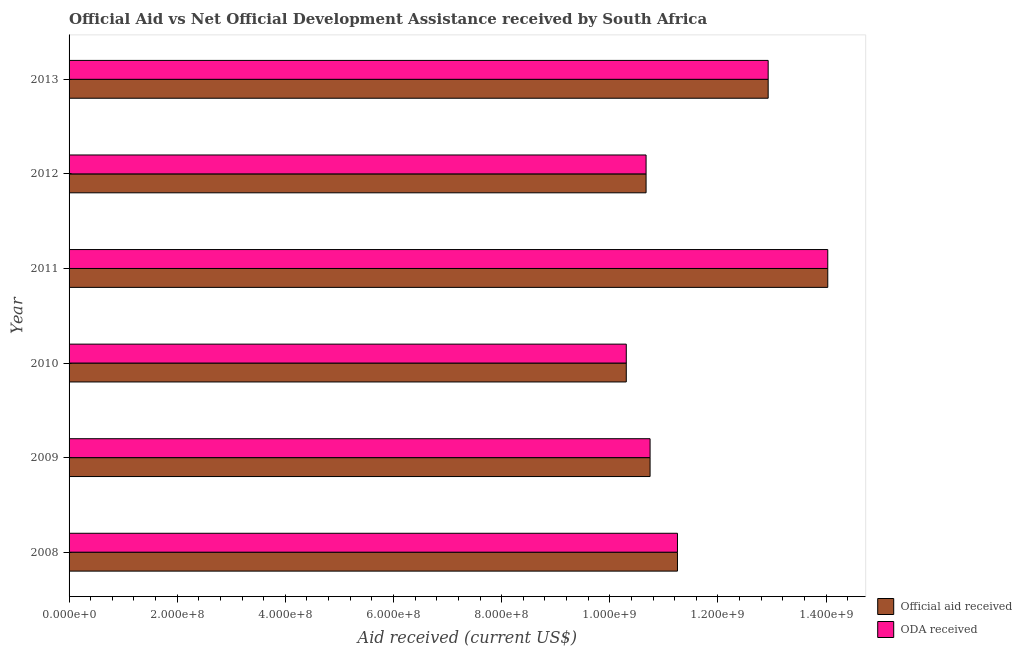How many different coloured bars are there?
Give a very brief answer. 2. Are the number of bars on each tick of the Y-axis equal?
Keep it short and to the point. Yes. What is the oda received in 2013?
Give a very brief answer. 1.29e+09. Across all years, what is the maximum oda received?
Give a very brief answer. 1.40e+09. Across all years, what is the minimum oda received?
Offer a very short reply. 1.03e+09. In which year was the oda received maximum?
Your answer should be compact. 2011. In which year was the oda received minimum?
Offer a terse response. 2010. What is the total oda received in the graph?
Give a very brief answer. 6.99e+09. What is the difference between the oda received in 2008 and that in 2010?
Keep it short and to the point. 9.46e+07. What is the difference between the oda received in 2013 and the official aid received in 2011?
Your answer should be very brief. -1.10e+08. What is the average official aid received per year?
Keep it short and to the point. 1.17e+09. In the year 2008, what is the difference between the oda received and official aid received?
Ensure brevity in your answer.  0. What is the ratio of the oda received in 2011 to that in 2013?
Make the answer very short. 1.08. Is the difference between the oda received in 2012 and 2013 greater than the difference between the official aid received in 2012 and 2013?
Keep it short and to the point. No. What is the difference between the highest and the second highest oda received?
Offer a very short reply. 1.10e+08. What is the difference between the highest and the lowest official aid received?
Offer a very short reply. 3.73e+08. Is the sum of the oda received in 2009 and 2011 greater than the maximum official aid received across all years?
Offer a terse response. Yes. What does the 1st bar from the top in 2008 represents?
Provide a short and direct response. ODA received. What does the 1st bar from the bottom in 2009 represents?
Make the answer very short. Official aid received. Are all the bars in the graph horizontal?
Give a very brief answer. Yes. How many years are there in the graph?
Ensure brevity in your answer.  6. What is the difference between two consecutive major ticks on the X-axis?
Offer a very short reply. 2.00e+08. Where does the legend appear in the graph?
Your answer should be very brief. Bottom right. How many legend labels are there?
Ensure brevity in your answer.  2. What is the title of the graph?
Your response must be concise. Official Aid vs Net Official Development Assistance received by South Africa . What is the label or title of the X-axis?
Make the answer very short. Aid received (current US$). What is the label or title of the Y-axis?
Offer a terse response. Year. What is the Aid received (current US$) of Official aid received in 2008?
Ensure brevity in your answer.  1.13e+09. What is the Aid received (current US$) of ODA received in 2008?
Provide a short and direct response. 1.13e+09. What is the Aid received (current US$) in Official aid received in 2009?
Your response must be concise. 1.07e+09. What is the Aid received (current US$) in ODA received in 2009?
Offer a terse response. 1.07e+09. What is the Aid received (current US$) in Official aid received in 2010?
Give a very brief answer. 1.03e+09. What is the Aid received (current US$) of ODA received in 2010?
Ensure brevity in your answer.  1.03e+09. What is the Aid received (current US$) in Official aid received in 2011?
Offer a terse response. 1.40e+09. What is the Aid received (current US$) in ODA received in 2011?
Make the answer very short. 1.40e+09. What is the Aid received (current US$) in Official aid received in 2012?
Keep it short and to the point. 1.07e+09. What is the Aid received (current US$) in ODA received in 2012?
Your answer should be very brief. 1.07e+09. What is the Aid received (current US$) of Official aid received in 2013?
Give a very brief answer. 1.29e+09. What is the Aid received (current US$) of ODA received in 2013?
Make the answer very short. 1.29e+09. Across all years, what is the maximum Aid received (current US$) in Official aid received?
Give a very brief answer. 1.40e+09. Across all years, what is the maximum Aid received (current US$) in ODA received?
Your answer should be very brief. 1.40e+09. Across all years, what is the minimum Aid received (current US$) in Official aid received?
Provide a short and direct response. 1.03e+09. Across all years, what is the minimum Aid received (current US$) of ODA received?
Provide a succinct answer. 1.03e+09. What is the total Aid received (current US$) in Official aid received in the graph?
Provide a short and direct response. 6.99e+09. What is the total Aid received (current US$) in ODA received in the graph?
Keep it short and to the point. 6.99e+09. What is the difference between the Aid received (current US$) in Official aid received in 2008 and that in 2009?
Provide a succinct answer. 5.06e+07. What is the difference between the Aid received (current US$) of ODA received in 2008 and that in 2009?
Give a very brief answer. 5.06e+07. What is the difference between the Aid received (current US$) of Official aid received in 2008 and that in 2010?
Offer a very short reply. 9.46e+07. What is the difference between the Aid received (current US$) in ODA received in 2008 and that in 2010?
Provide a succinct answer. 9.46e+07. What is the difference between the Aid received (current US$) of Official aid received in 2008 and that in 2011?
Provide a short and direct response. -2.78e+08. What is the difference between the Aid received (current US$) of ODA received in 2008 and that in 2011?
Your answer should be compact. -2.78e+08. What is the difference between the Aid received (current US$) of Official aid received in 2008 and that in 2012?
Keep it short and to the point. 5.80e+07. What is the difference between the Aid received (current US$) of ODA received in 2008 and that in 2012?
Your answer should be very brief. 5.80e+07. What is the difference between the Aid received (current US$) in Official aid received in 2008 and that in 2013?
Your response must be concise. -1.68e+08. What is the difference between the Aid received (current US$) in ODA received in 2008 and that in 2013?
Keep it short and to the point. -1.68e+08. What is the difference between the Aid received (current US$) of Official aid received in 2009 and that in 2010?
Offer a terse response. 4.40e+07. What is the difference between the Aid received (current US$) of ODA received in 2009 and that in 2010?
Ensure brevity in your answer.  4.40e+07. What is the difference between the Aid received (current US$) of Official aid received in 2009 and that in 2011?
Ensure brevity in your answer.  -3.29e+08. What is the difference between the Aid received (current US$) of ODA received in 2009 and that in 2011?
Your response must be concise. -3.29e+08. What is the difference between the Aid received (current US$) in Official aid received in 2009 and that in 2012?
Offer a very short reply. 7.39e+06. What is the difference between the Aid received (current US$) in ODA received in 2009 and that in 2012?
Offer a very short reply. 7.39e+06. What is the difference between the Aid received (current US$) of Official aid received in 2009 and that in 2013?
Your answer should be very brief. -2.18e+08. What is the difference between the Aid received (current US$) in ODA received in 2009 and that in 2013?
Make the answer very short. -2.18e+08. What is the difference between the Aid received (current US$) of Official aid received in 2010 and that in 2011?
Your answer should be compact. -3.73e+08. What is the difference between the Aid received (current US$) of ODA received in 2010 and that in 2011?
Make the answer very short. -3.73e+08. What is the difference between the Aid received (current US$) in Official aid received in 2010 and that in 2012?
Ensure brevity in your answer.  -3.66e+07. What is the difference between the Aid received (current US$) in ODA received in 2010 and that in 2012?
Provide a short and direct response. -3.66e+07. What is the difference between the Aid received (current US$) in Official aid received in 2010 and that in 2013?
Keep it short and to the point. -2.62e+08. What is the difference between the Aid received (current US$) of ODA received in 2010 and that in 2013?
Make the answer very short. -2.62e+08. What is the difference between the Aid received (current US$) of Official aid received in 2011 and that in 2012?
Provide a short and direct response. 3.36e+08. What is the difference between the Aid received (current US$) of ODA received in 2011 and that in 2012?
Keep it short and to the point. 3.36e+08. What is the difference between the Aid received (current US$) in Official aid received in 2011 and that in 2013?
Offer a very short reply. 1.10e+08. What is the difference between the Aid received (current US$) in ODA received in 2011 and that in 2013?
Your response must be concise. 1.10e+08. What is the difference between the Aid received (current US$) of Official aid received in 2012 and that in 2013?
Provide a succinct answer. -2.26e+08. What is the difference between the Aid received (current US$) in ODA received in 2012 and that in 2013?
Keep it short and to the point. -2.26e+08. What is the difference between the Aid received (current US$) in Official aid received in 2008 and the Aid received (current US$) in ODA received in 2009?
Your answer should be compact. 5.06e+07. What is the difference between the Aid received (current US$) in Official aid received in 2008 and the Aid received (current US$) in ODA received in 2010?
Your answer should be compact. 9.46e+07. What is the difference between the Aid received (current US$) of Official aid received in 2008 and the Aid received (current US$) of ODA received in 2011?
Provide a short and direct response. -2.78e+08. What is the difference between the Aid received (current US$) in Official aid received in 2008 and the Aid received (current US$) in ODA received in 2012?
Offer a terse response. 5.80e+07. What is the difference between the Aid received (current US$) in Official aid received in 2008 and the Aid received (current US$) in ODA received in 2013?
Keep it short and to the point. -1.68e+08. What is the difference between the Aid received (current US$) of Official aid received in 2009 and the Aid received (current US$) of ODA received in 2010?
Offer a very short reply. 4.40e+07. What is the difference between the Aid received (current US$) in Official aid received in 2009 and the Aid received (current US$) in ODA received in 2011?
Your response must be concise. -3.29e+08. What is the difference between the Aid received (current US$) in Official aid received in 2009 and the Aid received (current US$) in ODA received in 2012?
Your answer should be very brief. 7.39e+06. What is the difference between the Aid received (current US$) of Official aid received in 2009 and the Aid received (current US$) of ODA received in 2013?
Keep it short and to the point. -2.18e+08. What is the difference between the Aid received (current US$) of Official aid received in 2010 and the Aid received (current US$) of ODA received in 2011?
Ensure brevity in your answer.  -3.73e+08. What is the difference between the Aid received (current US$) of Official aid received in 2010 and the Aid received (current US$) of ODA received in 2012?
Offer a very short reply. -3.66e+07. What is the difference between the Aid received (current US$) of Official aid received in 2010 and the Aid received (current US$) of ODA received in 2013?
Provide a short and direct response. -2.62e+08. What is the difference between the Aid received (current US$) in Official aid received in 2011 and the Aid received (current US$) in ODA received in 2012?
Your answer should be very brief. 3.36e+08. What is the difference between the Aid received (current US$) of Official aid received in 2011 and the Aid received (current US$) of ODA received in 2013?
Give a very brief answer. 1.10e+08. What is the difference between the Aid received (current US$) in Official aid received in 2012 and the Aid received (current US$) in ODA received in 2013?
Give a very brief answer. -2.26e+08. What is the average Aid received (current US$) in Official aid received per year?
Keep it short and to the point. 1.17e+09. What is the average Aid received (current US$) of ODA received per year?
Your answer should be compact. 1.17e+09. In the year 2008, what is the difference between the Aid received (current US$) in Official aid received and Aid received (current US$) in ODA received?
Give a very brief answer. 0. In the year 2010, what is the difference between the Aid received (current US$) of Official aid received and Aid received (current US$) of ODA received?
Offer a very short reply. 0. In the year 2012, what is the difference between the Aid received (current US$) of Official aid received and Aid received (current US$) of ODA received?
Your response must be concise. 0. What is the ratio of the Aid received (current US$) in Official aid received in 2008 to that in 2009?
Your answer should be compact. 1.05. What is the ratio of the Aid received (current US$) of ODA received in 2008 to that in 2009?
Offer a terse response. 1.05. What is the ratio of the Aid received (current US$) in Official aid received in 2008 to that in 2010?
Make the answer very short. 1.09. What is the ratio of the Aid received (current US$) of ODA received in 2008 to that in 2010?
Ensure brevity in your answer.  1.09. What is the ratio of the Aid received (current US$) in Official aid received in 2008 to that in 2011?
Provide a short and direct response. 0.8. What is the ratio of the Aid received (current US$) in ODA received in 2008 to that in 2011?
Give a very brief answer. 0.8. What is the ratio of the Aid received (current US$) of Official aid received in 2008 to that in 2012?
Your answer should be compact. 1.05. What is the ratio of the Aid received (current US$) in ODA received in 2008 to that in 2012?
Offer a terse response. 1.05. What is the ratio of the Aid received (current US$) of Official aid received in 2008 to that in 2013?
Give a very brief answer. 0.87. What is the ratio of the Aid received (current US$) in ODA received in 2008 to that in 2013?
Your answer should be compact. 0.87. What is the ratio of the Aid received (current US$) of Official aid received in 2009 to that in 2010?
Your response must be concise. 1.04. What is the ratio of the Aid received (current US$) in ODA received in 2009 to that in 2010?
Your answer should be very brief. 1.04. What is the ratio of the Aid received (current US$) in Official aid received in 2009 to that in 2011?
Provide a short and direct response. 0.77. What is the ratio of the Aid received (current US$) in ODA received in 2009 to that in 2011?
Provide a succinct answer. 0.77. What is the ratio of the Aid received (current US$) in Official aid received in 2009 to that in 2013?
Offer a terse response. 0.83. What is the ratio of the Aid received (current US$) of ODA received in 2009 to that in 2013?
Ensure brevity in your answer.  0.83. What is the ratio of the Aid received (current US$) in Official aid received in 2010 to that in 2011?
Give a very brief answer. 0.73. What is the ratio of the Aid received (current US$) of ODA received in 2010 to that in 2011?
Make the answer very short. 0.73. What is the ratio of the Aid received (current US$) of Official aid received in 2010 to that in 2012?
Give a very brief answer. 0.97. What is the ratio of the Aid received (current US$) in ODA received in 2010 to that in 2012?
Offer a very short reply. 0.97. What is the ratio of the Aid received (current US$) of Official aid received in 2010 to that in 2013?
Offer a terse response. 0.8. What is the ratio of the Aid received (current US$) in ODA received in 2010 to that in 2013?
Make the answer very short. 0.8. What is the ratio of the Aid received (current US$) of Official aid received in 2011 to that in 2012?
Provide a short and direct response. 1.31. What is the ratio of the Aid received (current US$) of ODA received in 2011 to that in 2012?
Keep it short and to the point. 1.31. What is the ratio of the Aid received (current US$) in Official aid received in 2011 to that in 2013?
Provide a succinct answer. 1.09. What is the ratio of the Aid received (current US$) in ODA received in 2011 to that in 2013?
Give a very brief answer. 1.09. What is the ratio of the Aid received (current US$) in Official aid received in 2012 to that in 2013?
Offer a very short reply. 0.83. What is the ratio of the Aid received (current US$) of ODA received in 2012 to that in 2013?
Keep it short and to the point. 0.83. What is the difference between the highest and the second highest Aid received (current US$) in Official aid received?
Give a very brief answer. 1.10e+08. What is the difference between the highest and the second highest Aid received (current US$) of ODA received?
Your answer should be compact. 1.10e+08. What is the difference between the highest and the lowest Aid received (current US$) of Official aid received?
Your response must be concise. 3.73e+08. What is the difference between the highest and the lowest Aid received (current US$) in ODA received?
Give a very brief answer. 3.73e+08. 